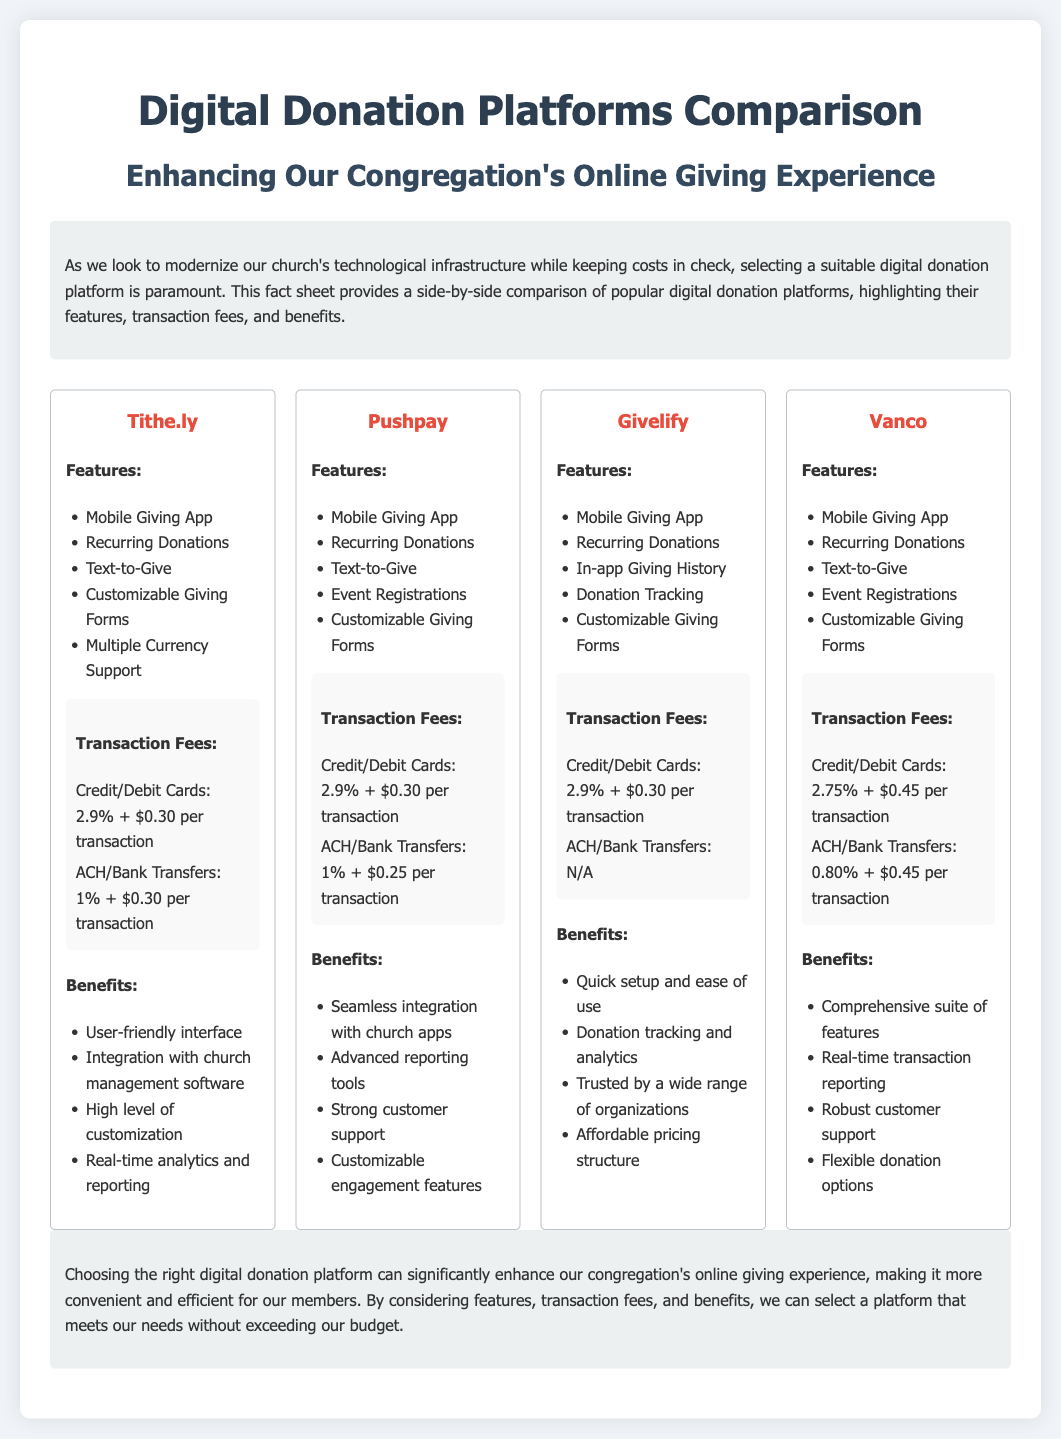What are the transaction fees for Tithe.ly? The transaction fees for Tithe.ly are 2.9% + $0.30 per transaction for credit/debit cards and 1% + $0.30 per transaction for ACH/bank transfers.
Answer: 2.9% + $0.30 (credit/debit), 1% + $0.30 (ACH) What is a key feature of Givelify? One key feature of Givelify is in-app giving history.
Answer: In-app Giving History Which platform has the lowest transaction fee for ACH/bank transfers? Vanco has the lowest transaction fee for ACH/bank transfers at 0.80% + $0.45 per transaction.
Answer: Vanco: 0.80% + $0.45 How many platforms offer a mobile giving app? All four platforms listed offer a mobile giving app as a feature.
Answer: Four What benefits does Pushpay provide? Benefits of Pushpay include advanced reporting tools and strong customer support.
Answer: Advanced reporting tools, strong customer support Which platform provides real-time analytics and reporting? Tithe.ly provides real-time analytics and reporting as a benefit.
Answer: Tithe.ly What document type is this comparison? This document is a fact sheet comparing digital donation platforms.
Answer: Fact sheet Which platform does not offer ACH/bank transfer transaction fees? Givelify does not offer ACH/bank transfer transaction fees.
Answer: Givelify 